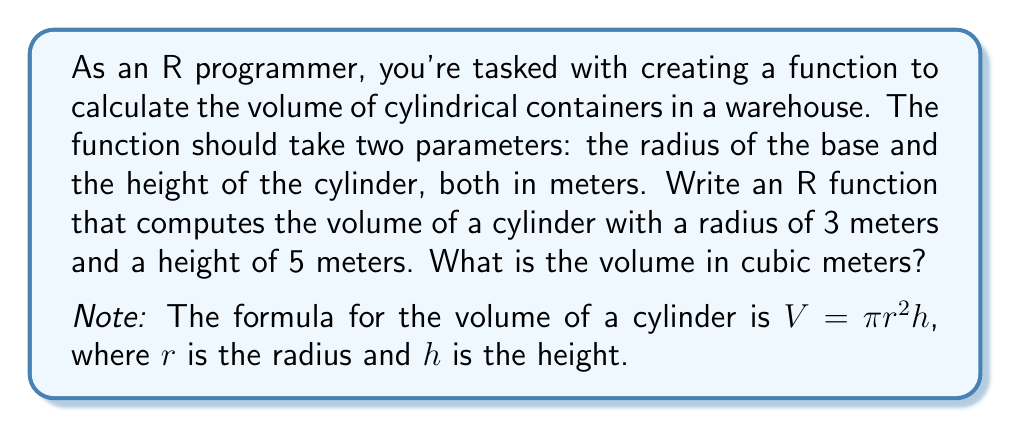What is the answer to this math problem? To solve this problem, we'll follow these steps:

1. Create an R function to calculate the volume of a cylinder:
   ```R
   cylinder_volume <- function(radius, height) {
     volume <- pi * radius^2 * height
     return(volume)
   }
   ```

2. Use the given values:
   - Radius ($r$) = 3 meters
   - Height ($h$) = 5 meters

3. Apply the formula $V = \pi r^2 h$:
   $$V = \pi \cdot 3^2 \cdot 5$$

4. Simplify:
   $$V = \pi \cdot 9 \cdot 5 = 45\pi$$

5. Calculate the final value:
   $$V \approx 45 \cdot 3.14159 \approx 141.37$$

In R, you would call the function like this:
```R
result <- cylinder_volume(3, 5)
print(result)
```

This would output approximately 141.3717 cubic meters.
Answer: The volume of the cylinder is $45\pi$ cubic meters, or approximately 141.37 cubic meters. 